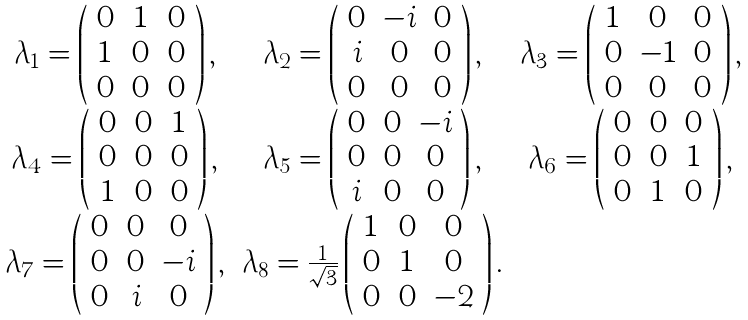<formula> <loc_0><loc_0><loc_500><loc_500>\begin{array} { c c c } \lambda _ { 1 } = \left ( \begin{array} { c c c } 0 & 1 & 0 \\ 1 & 0 & 0 \\ 0 & 0 & 0 \end{array} \right ) , & \lambda _ { 2 } = \left ( \begin{array} { c c c } 0 & - i & 0 \\ i & 0 & 0 \\ 0 & 0 & 0 \end{array} \right ) , & \lambda _ { 3 } = \left ( \begin{array} { c c c } 1 & 0 & 0 \\ 0 & - 1 & 0 \\ 0 & 0 & 0 \end{array} \right ) , \\ \lambda _ { 4 } = \left ( \begin{array} { c c c } 0 & 0 & 1 \\ 0 & 0 & 0 \\ 1 & 0 & 0 \end{array} \right ) , & \lambda _ { 5 } = \left ( \begin{array} { c c c } 0 & 0 & - i \\ 0 & 0 & 0 \\ i & 0 & 0 \end{array} \right ) , & \lambda _ { 6 } = \left ( \begin{array} { c c c } 0 & 0 & 0 \\ 0 & 0 & 1 \\ 0 & 1 & 0 \end{array} \right ) , \\ \lambda _ { 7 } = \left ( \begin{array} { c c c } 0 & 0 & 0 \\ 0 & 0 & - i \\ 0 & i & 0 \end{array} \right ) , & \lambda _ { 8 } = \frac { 1 } { \sqrt { 3 } } \left ( \begin{array} { c c c } 1 & 0 & 0 \\ 0 & 1 & 0 \\ 0 & 0 & - 2 \end{array} \right ) . & \\ \end{array}</formula> 